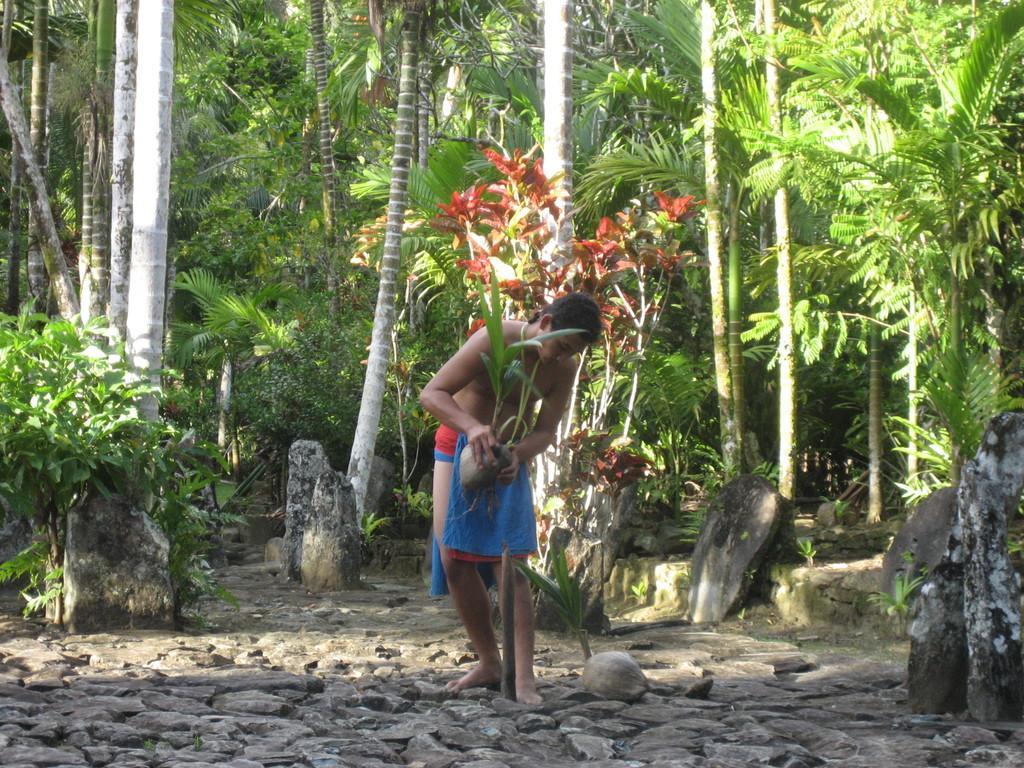Could you give a brief overview of what you see in this image? In this image we can see there are trees, plants and stones. And there is the person standing on the ground and holding a potted plant. 